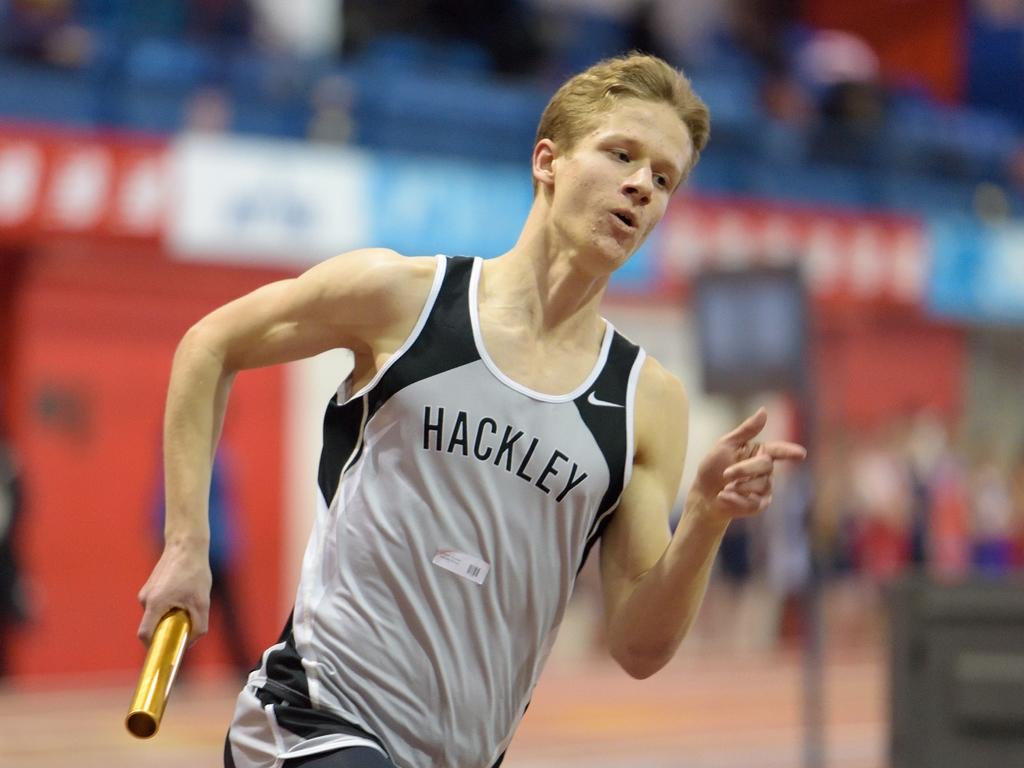What is on his shirt?
Provide a succinct answer. Hackley. What brand is he wearing?
Your answer should be compact. Nike. 